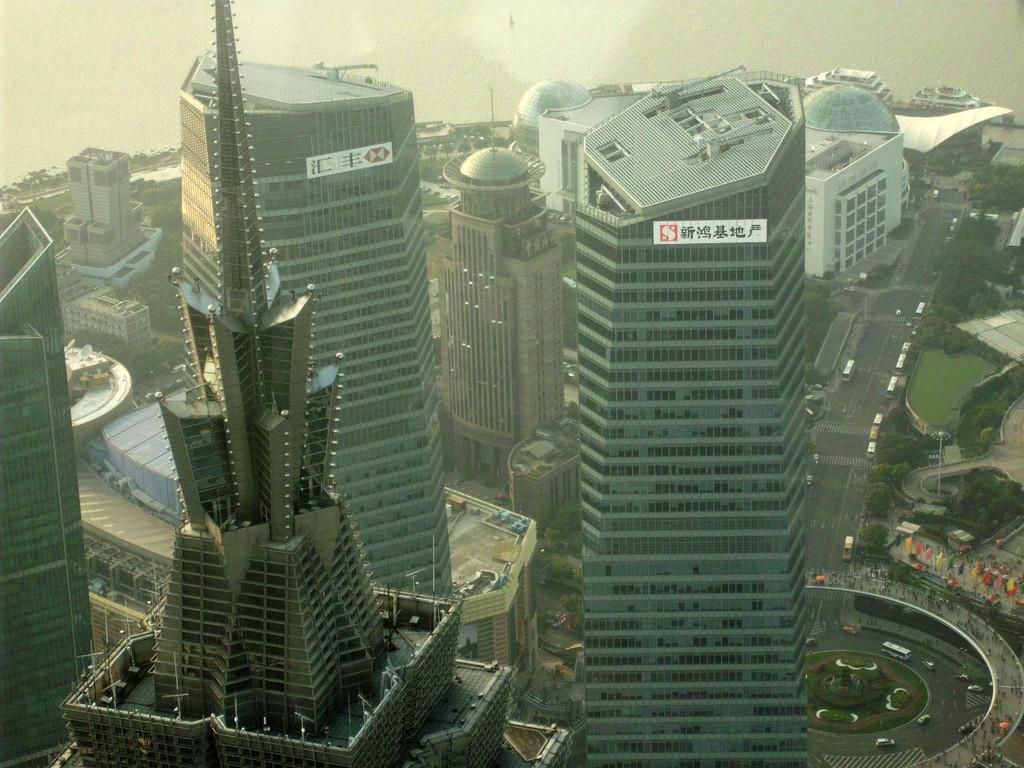What type of structures can be seen in the image? There are buildings in the image. What is visible beneath the buildings and trees? The ground is visible in the image. What type of vegetation is present in the image? There is grass and trees in the image. What else can be seen moving around in the image? There are vehicles in the image. What decorative elements are present in the image? There are flags in the image. What part of the natural environment is visible in the image? The sky is visible in the image. What type of clam can be seen swimming in the sky in the image? There are no clams present in the image, and the sky is not a suitable environment for clams to swim in. What color is the star that is shining above the trees in the image? There are no stars visible in the image; only the sky is visible. 